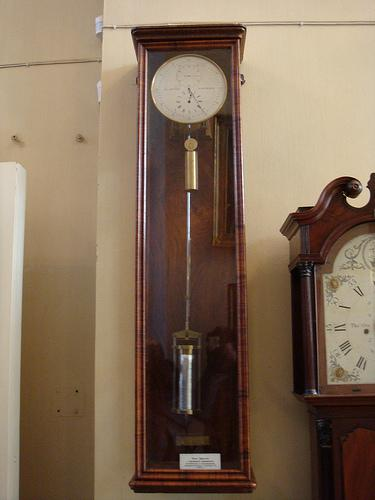For product advertisement, describe one unique feature of the clock that sets it apart from conventional time-telling devices. The clock does not seem to tell conventional time with its several different dials on the clock face. In the visual entailment task, describe a contrast between the main subject and its surroundings. The main subject, a brown grandfather clock, stands out against a white clock with a cord along the wall. In the multi-choice VQA task, mention what color the pendulum is and describe its position or movement. The pendulum is gold and is swinging, maintaining the clock's function. Identify the numbering style on the clock's face and describe the color and material of the clock frame. The clock's face has Roman numerals in black and the frame is made of brown wood. What is the color and style of the clock in the image? The clock is a dark brown wood floor clock with a classic grandfather style. What part of the clock is in motion to keep it running? The pendulum swings back and forth to keep the clock running. For a referential expression grounding task, point out the type of nail used to hang the clock on the wall. There are two nails in the wall serving as the hanging mechanism for the clock. What color is the label on the image and what is its content? The label is white with black writing providing details about the clock on display. Mention a type of numeral that the image's clock is using to display the hour. The clock uses Roman numerals to display the hour. Describe an interesting feature on the clock face. There is a decorative design on the analog clock face. 